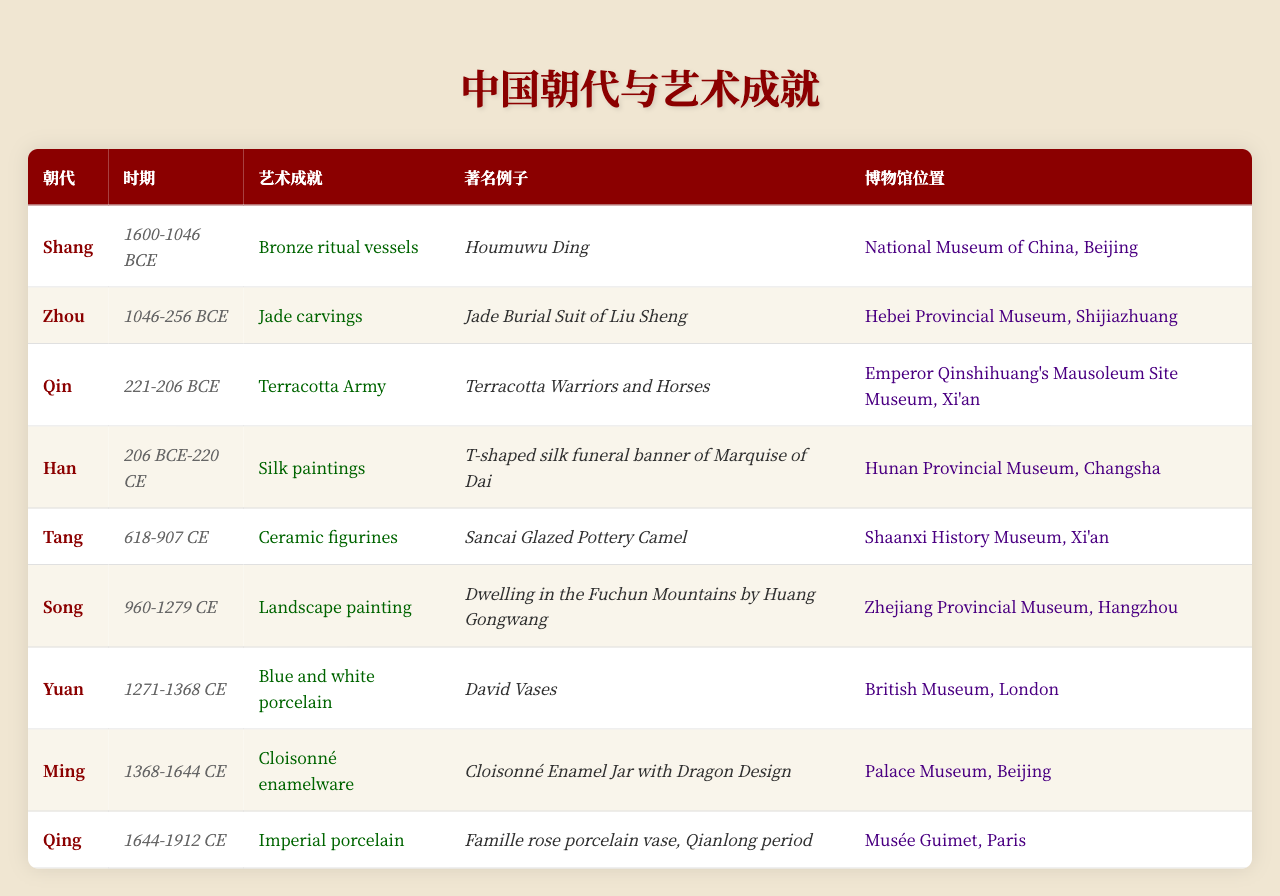What artistic achievement is associated with the Han dynasty? The table lists "Silk paintings" as the artistic achievement associated with the Han dynasty.
Answer: Silk paintings Which museum holds the notable example of the Houmuwu Ding? The table indicates that the Houmuwu Ding is located in the National Museum of China in Beijing.
Answer: National Museum of China, Beijing What are the periods of the Qing dynasty in the table? The table states that the period of the Qing dynasty is from 1644 to 1912 CE.
Answer: 1644-1912 CE Does the Tang dynasty feature landscape painting as an artistic achievement? Referring to the table, it is clear that the Tang dynasty is associated with "Ceramic figurines," not landscape painting.
Answer: No Which dynasty is known for its blue and white porcelain? According to the table, the Yuan dynasty is noted for its blue and white porcelain achievements.
Answer: Yuan dynasty Are there more artistic achievements linked to the Zhou dynasty or the Ming dynasty? The table shows one achievement each for the Zhou dynasty (Jade carvings) and the Ming dynasty (Cloisonné enamelware); thus, they are equal in number.
Answer: Equal Name one notable example of the artistic achievement during the Song dynasty. The notable example during the Song dynasty as per the table is "Dwelling in the Fuchun Mountains by Huang Gongwang."
Answer: Dwelling in the Fuchun Mountains by Huang Gongwang What is the notable example of terracotta from the Qin dynasty? The table specifies that the notable example of the terracotta artistic achievement from the Qin dynasty is "Terracotta Warriors and Horses."
Answer: Terracotta Warriors and Horses How do the periods of the Shang and Han dynasties compare in terms of years? The Shang dynasty spans 1600-1046 BCE (approx. 554 years) while the Han dynasty spans 206 BCE-220 CE (approx. 426 years). The Shang dynasty period is longer by about 128 years.
Answer: Shang dynasty is longer by about 128 years Which dynasty’s artistic achievements feature in the British Museum? The table indicates that the Yuan dynasty's blue and white porcelain, specifically the David Vases, is in the British Museum.
Answer: Yuan dynasty 